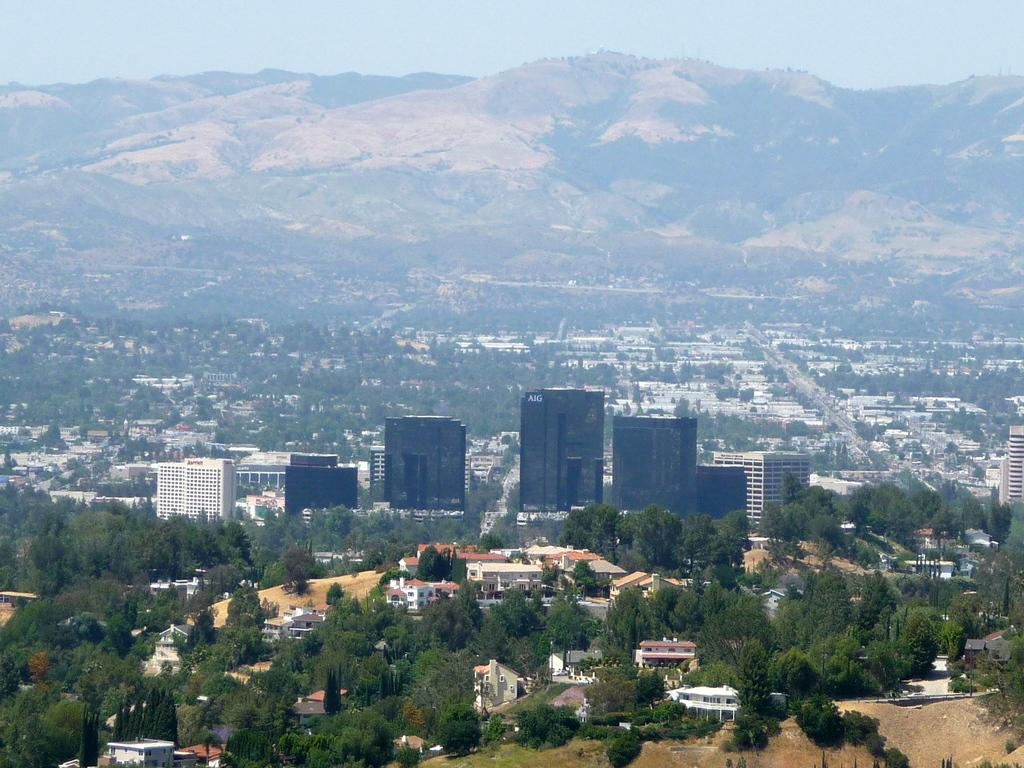What type of structures can be seen in the image? There are many buildings in the image. What other natural elements are present in the image? There are trees in the image. What can be seen in the distance in the image? There are hills in the background of the image. What is visible at the top of the image? The sky is visible at the top of the image. What type of feast is being prepared in the image? There is no indication of a feast or any food preparation in the image. Can you tell me the story behind the buildings in the image? The image does not provide any information about the history or story behind the buildings. 